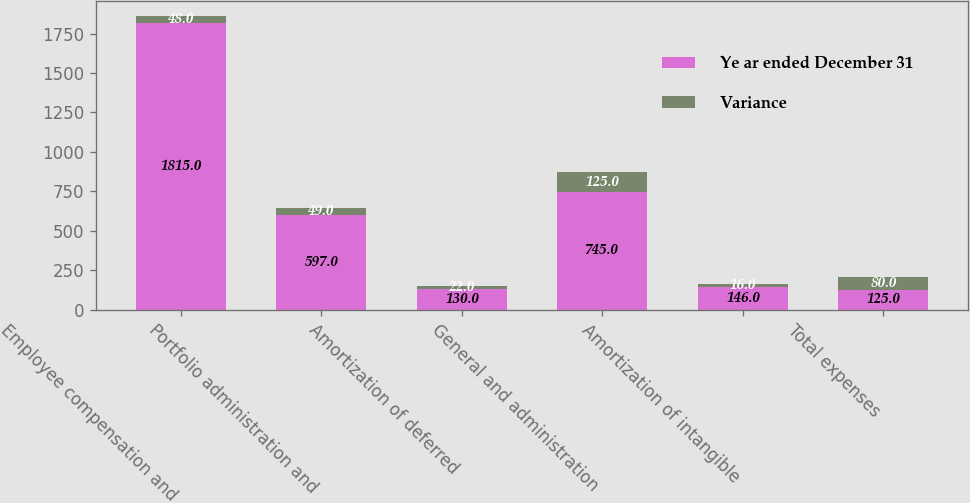Convert chart. <chart><loc_0><loc_0><loc_500><loc_500><stacked_bar_chart><ecel><fcel>Employee compensation and<fcel>Portfolio administration and<fcel>Amortization of deferred<fcel>General and administration<fcel>Amortization of intangible<fcel>Total expenses<nl><fcel>Ye ar ended December 31<fcel>1815<fcel>597<fcel>130<fcel>745<fcel>146<fcel>125<nl><fcel>Variance<fcel>48<fcel>49<fcel>22<fcel>125<fcel>16<fcel>80<nl></chart> 